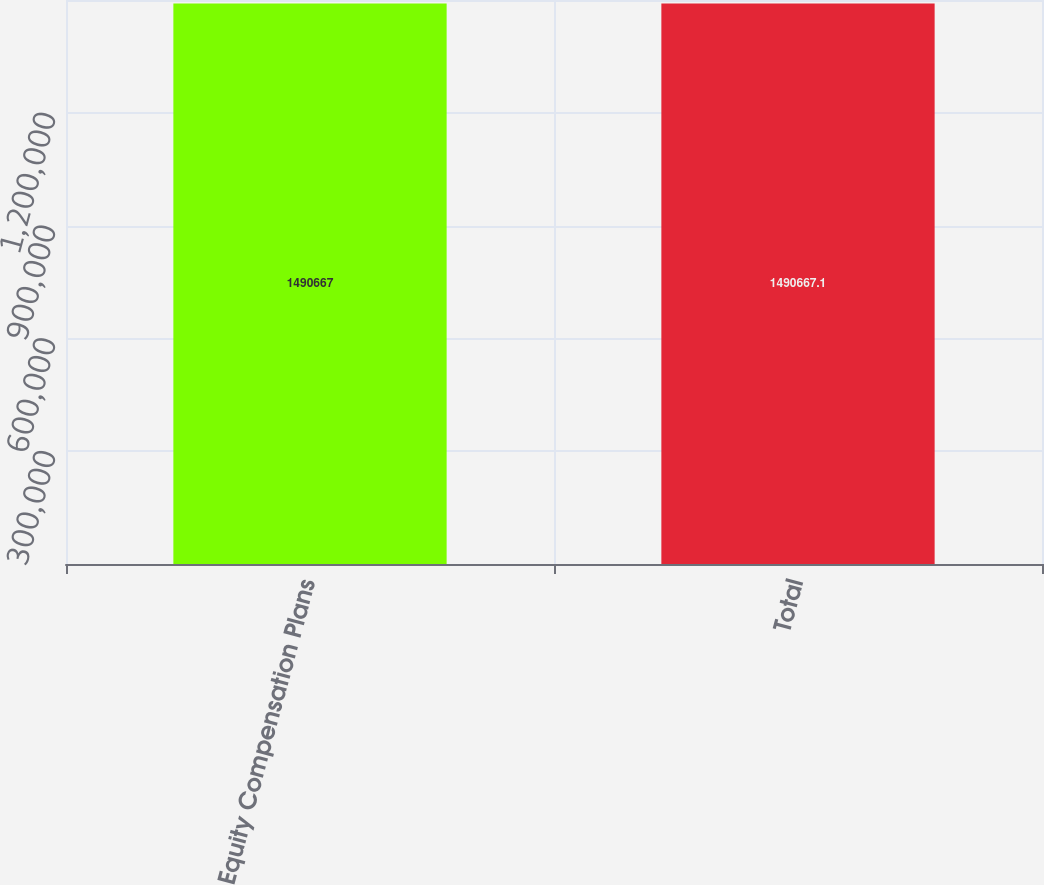Convert chart. <chart><loc_0><loc_0><loc_500><loc_500><bar_chart><fcel>Equity Compensation Plans<fcel>Total<nl><fcel>1.49067e+06<fcel>1.49067e+06<nl></chart> 